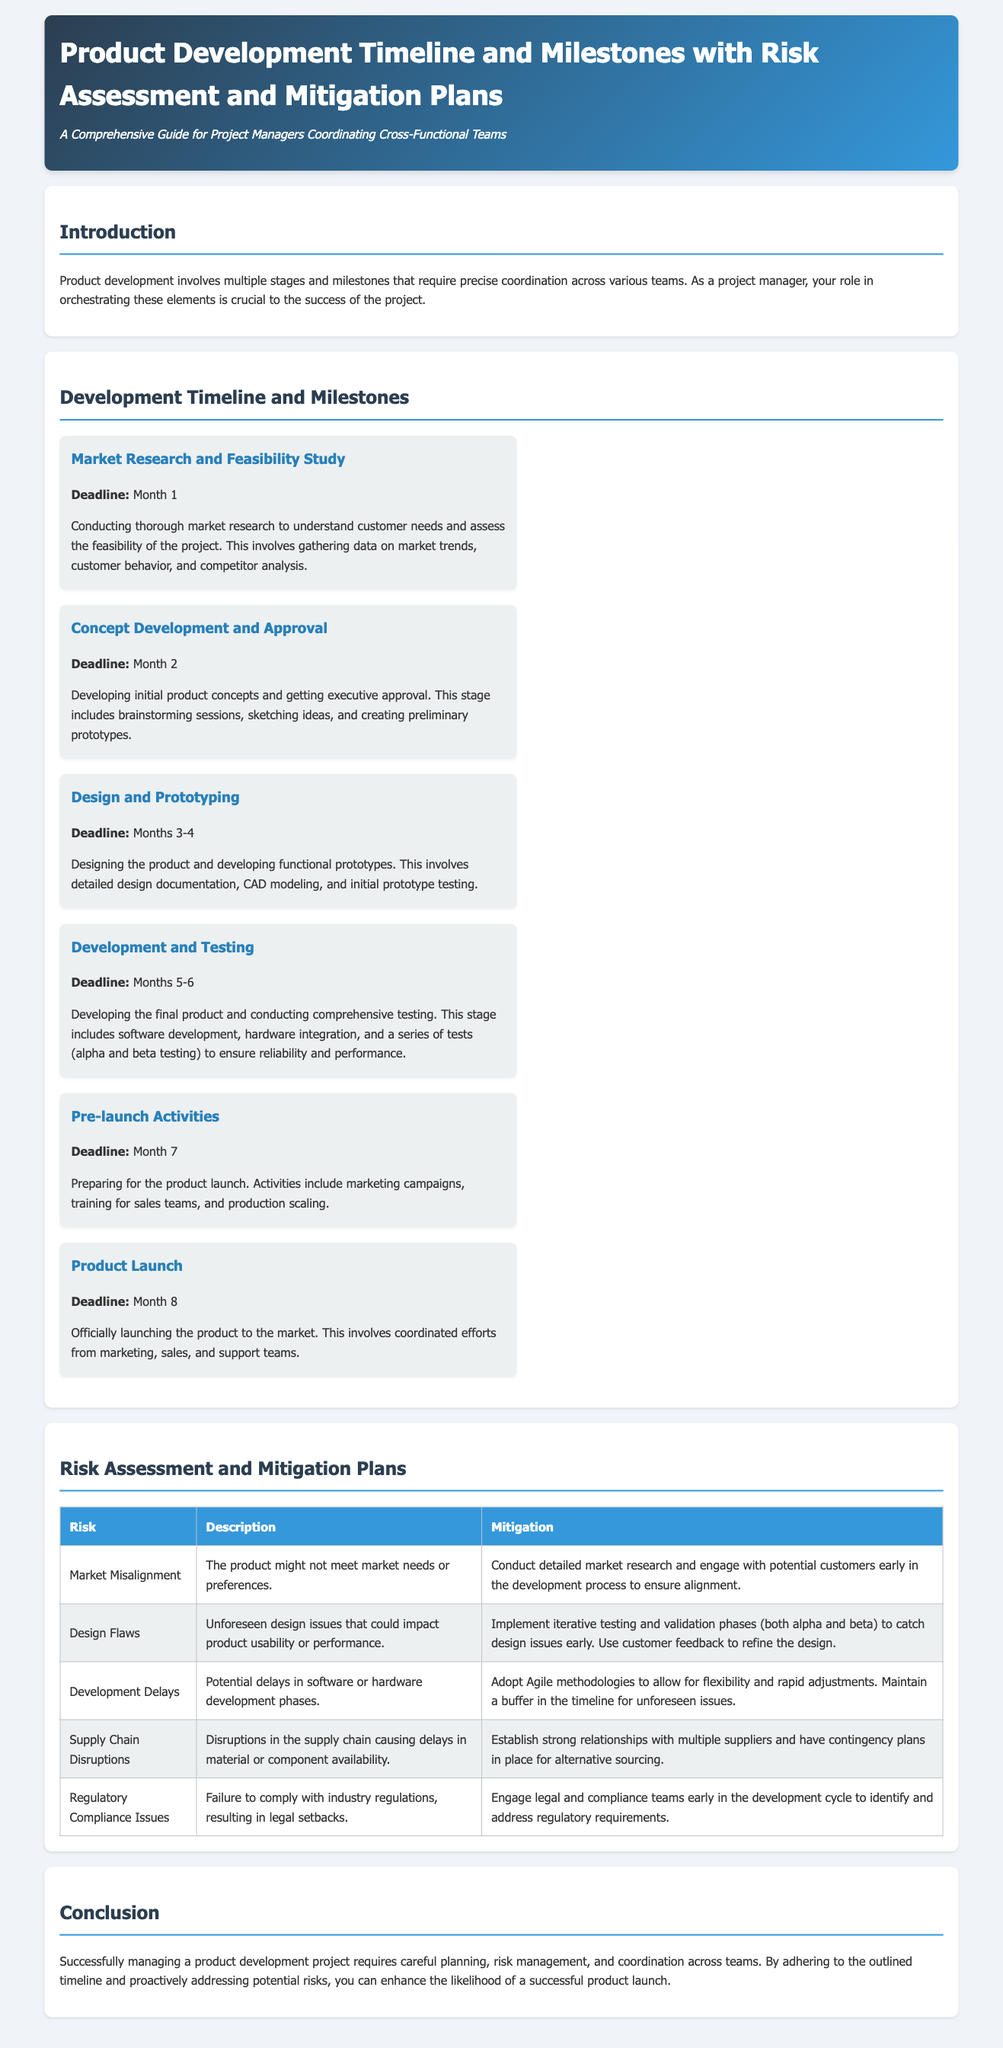What is the first milestone in the timeline? The first milestone is the "Market Research and Feasibility Study," which is detailed in the document.
Answer: Market Research and Feasibility Study What is the deadline for the "Product Launch"? The deadline for the "Product Launch" is specified as Month 8 in the document.
Answer: Month 8 What risk involves the product not meeting market needs? The risk involving the product not meeting market needs is described as "Market Misalignment."
Answer: Market Misalignment How many months are allocated for "Design and Prototyping"? The document states that "Design and Prototyping" takes place over 2 months, specifically Months 3-4.
Answer: Months 3-4 What is the mitigation plan for "Development Delays"? The mitigation for "Development Delays" involves adopting Agile methodologies.
Answer: Adopting Agile methodologies What do you need to engage with early to avoid regulatory issues? To avoid regulatory issues, you need to engage with legal and compliance teams early in the development cycle.
Answer: Legal and compliance teams Which milestone includes preparing for product launch? The milestone that includes preparing for the product launch is "Pre-launch Activities."
Answer: Pre-launch Activities What are the product development phases mentioned in this document? The document outlines several phases: Market Research, Concept Development, Design, Development, Pre-launch, and Launch.
Answer: Market Research, Concept Development, Design, Development, Pre-launch, Launch What is indicated as a potential risk related to supply? "Supply Chain Disruptions" are indicated as a potential risk in relation to supply.
Answer: Supply Chain Disruptions 